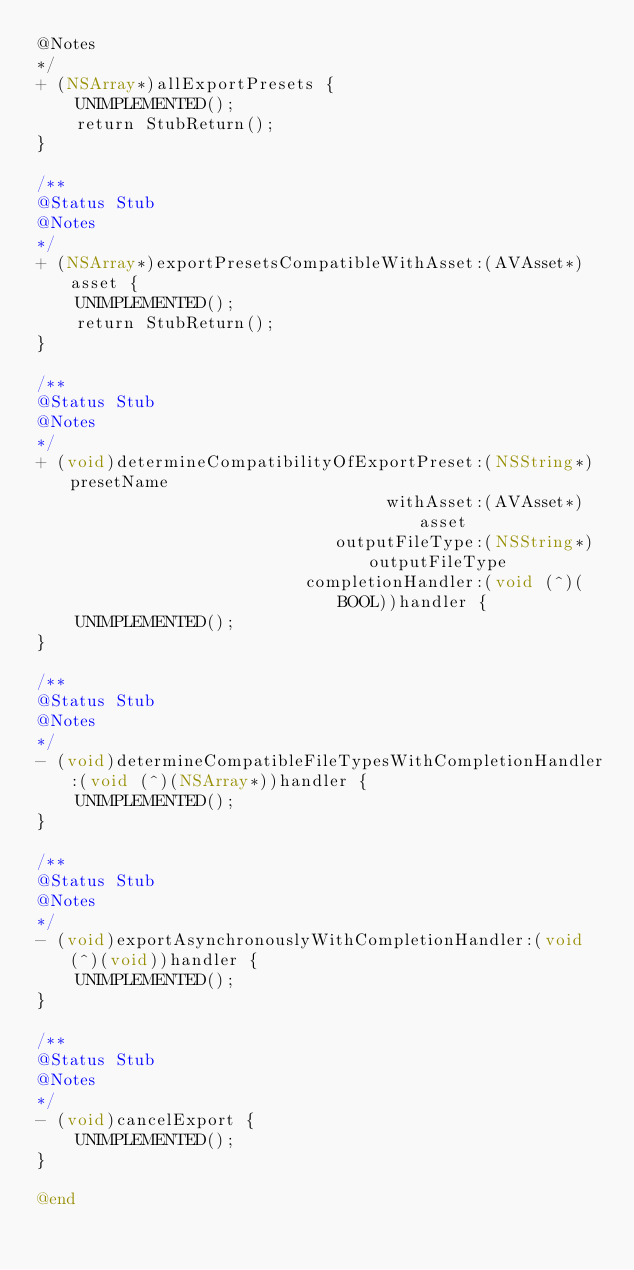<code> <loc_0><loc_0><loc_500><loc_500><_ObjectiveC_>@Notes
*/
+ (NSArray*)allExportPresets {
    UNIMPLEMENTED();
    return StubReturn();
}

/**
@Status Stub
@Notes
*/
+ (NSArray*)exportPresetsCompatibleWithAsset:(AVAsset*)asset {
    UNIMPLEMENTED();
    return StubReturn();
}

/**
@Status Stub
@Notes
*/
+ (void)determineCompatibilityOfExportPreset:(NSString*)presetName
                                   withAsset:(AVAsset*)asset
                              outputFileType:(NSString*)outputFileType
                           completionHandler:(void (^)(BOOL))handler {
    UNIMPLEMENTED();
}

/**
@Status Stub
@Notes
*/
- (void)determineCompatibleFileTypesWithCompletionHandler:(void (^)(NSArray*))handler {
    UNIMPLEMENTED();
}

/**
@Status Stub
@Notes
*/
- (void)exportAsynchronouslyWithCompletionHandler:(void (^)(void))handler {
    UNIMPLEMENTED();
}

/**
@Status Stub
@Notes
*/
- (void)cancelExport {
    UNIMPLEMENTED();
}

@end
</code> 